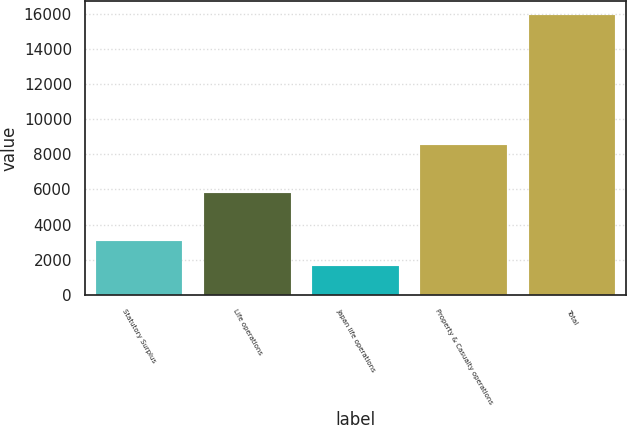Convert chart. <chart><loc_0><loc_0><loc_500><loc_500><bar_chart><fcel>Statutory Surplus<fcel>Life operations<fcel>Japan life operations<fcel>Property & Casualty operations<fcel>Total<nl><fcel>3049.5<fcel>5786<fcel>1620<fcel>8509<fcel>15915<nl></chart> 